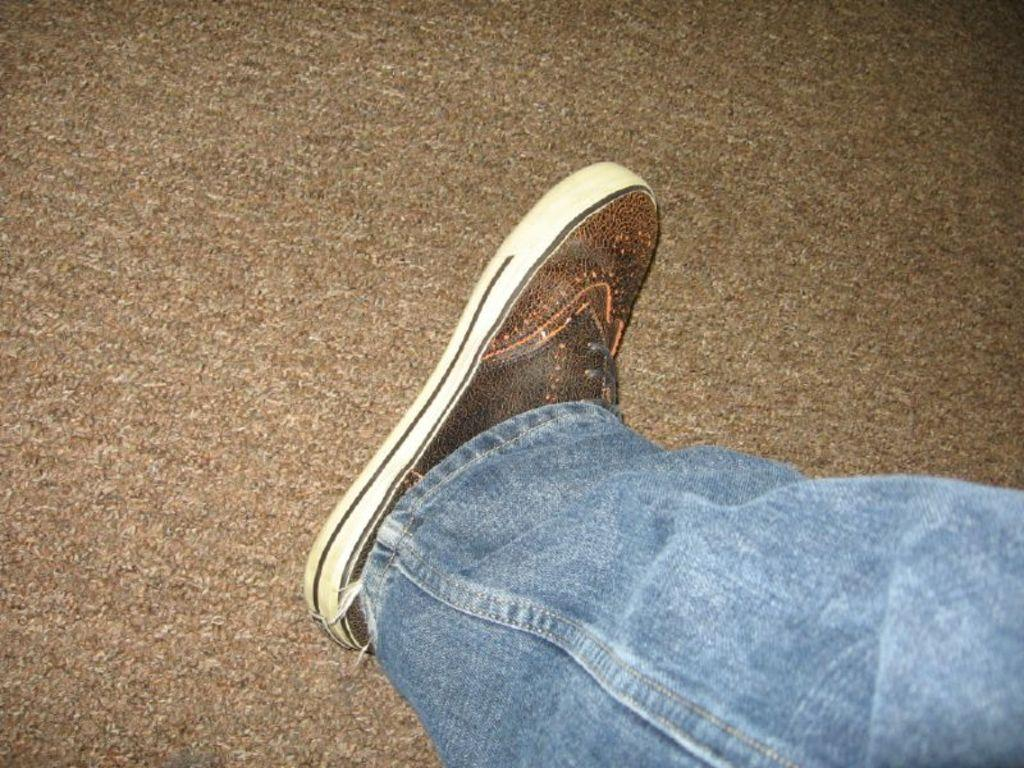What part of a person can be seen in the image? There is a leg of a person in the image. Where is the leg positioned in the image? The leg is on a platform. What type of footwear is the person wearing? There is a worn shoe attached to the leg. How many snakes are crawling on the leg in the image? There are no snakes present in the image; only a leg and a worn shoe can be seen. What type of frogs can be seen hopping on the platform in the image? There are no frogs present in the image; only a leg and a worn shoe can be seen. 